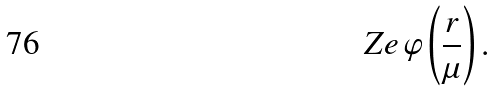Convert formula to latex. <formula><loc_0><loc_0><loc_500><loc_500>Z e \, \varphi \left ( \frac { r } { \mu } \right ) .</formula> 